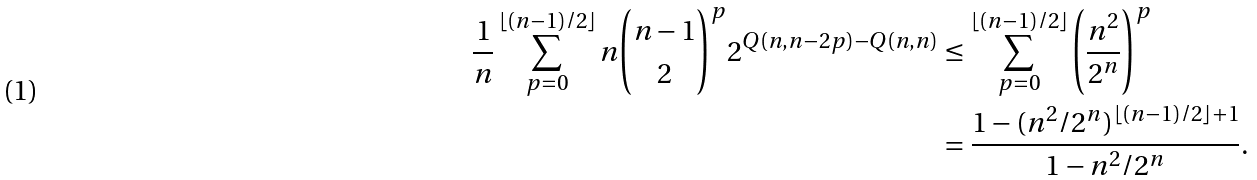<formula> <loc_0><loc_0><loc_500><loc_500>\frac { 1 } { n } \sum _ { p = 0 } ^ { \lfloor ( n - 1 ) / 2 \rfloor } n \binom { n - 1 } { 2 } ^ { p } 2 ^ { Q ( n , n - 2 p ) - Q ( n , n ) } & \leq \sum _ { p = 0 } ^ { \lfloor ( n - 1 ) / 2 \rfloor } \left ( \frac { n ^ { 2 } } { 2 ^ { n } } \right ) ^ { p } \\ & = \frac { 1 - ( n ^ { 2 } / 2 ^ { n } ) ^ { \lfloor ( n - 1 ) / 2 \rfloor + 1 } } { 1 - n ^ { 2 } / 2 ^ { n } } .</formula> 